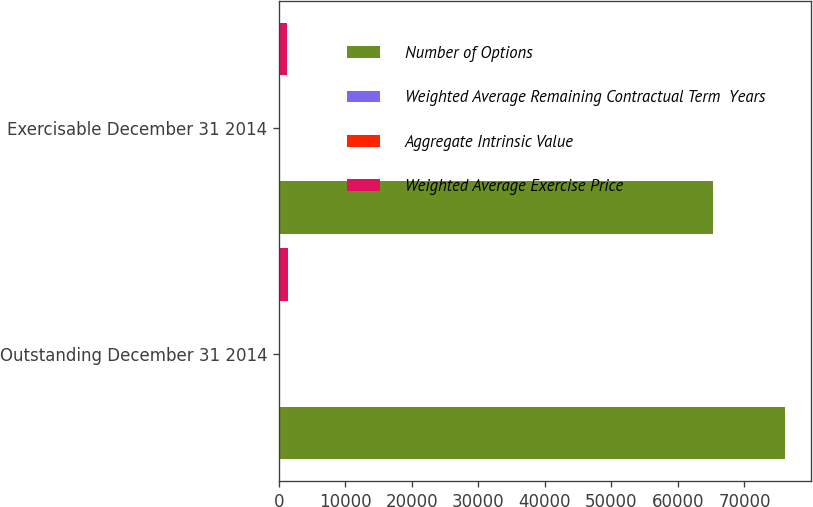<chart> <loc_0><loc_0><loc_500><loc_500><stacked_bar_chart><ecel><fcel>Outstanding December 31 2014<fcel>Exercisable December 31 2014<nl><fcel>Number of Options<fcel>76135<fcel>65324<nl><fcel>Weighted Average Remaining Contractual Term  Years<fcel>39.05<fcel>37.56<nl><fcel>Aggregate Intrinsic Value<fcel>3.85<fcel>3.21<nl><fcel>Weighted Average Exercise Price<fcel>1358<fcel>1257<nl></chart> 